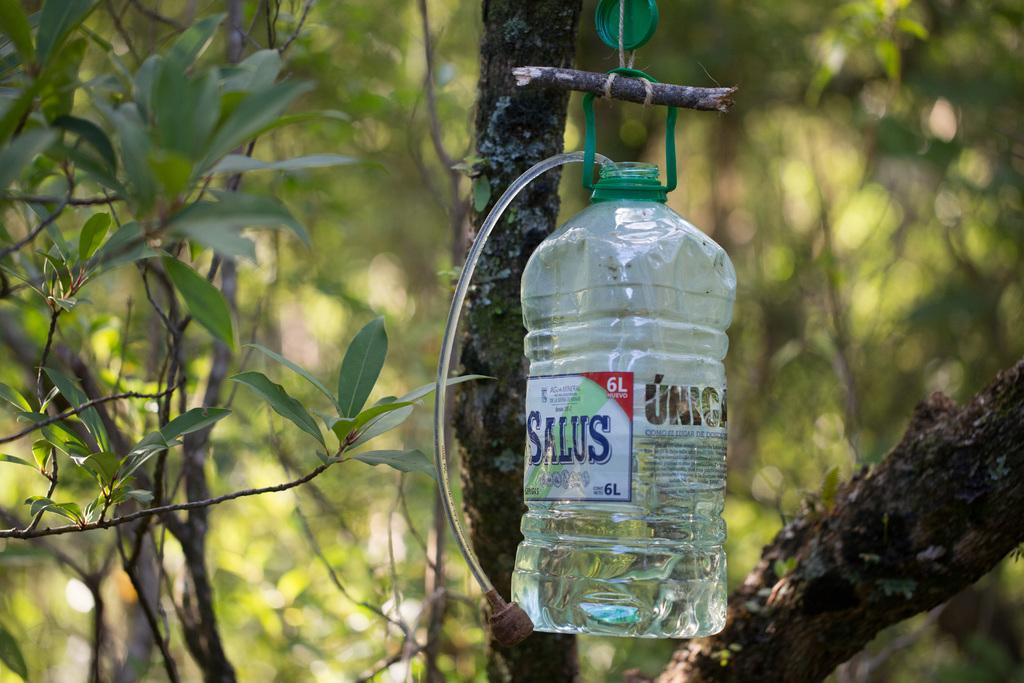What object can be seen hanging from a tree in the image? There is a bottle hanging from a tree in the image. What is the purpose of the label on the bottle? The label on the bottle provides information about its contents or origin. Is there any coal visible in the image? No, there is no coal present in the image. What type of cover is on the bottle in the image? The facts provided do not mention a cover on the bottle, so we cannot determine if there is one or what type it might be. 